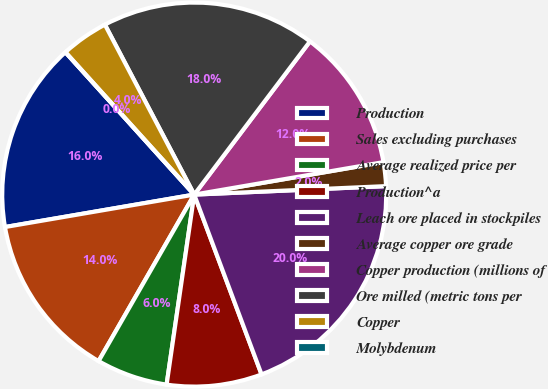<chart> <loc_0><loc_0><loc_500><loc_500><pie_chart><fcel>Production<fcel>Sales excluding purchases<fcel>Average realized price per<fcel>Production^a<fcel>Leach ore placed in stockpiles<fcel>Average copper ore grade<fcel>Copper production (millions of<fcel>Ore milled (metric tons per<fcel>Copper<fcel>Molybdenum<nl><fcel>16.0%<fcel>14.0%<fcel>6.0%<fcel>8.0%<fcel>20.0%<fcel>2.0%<fcel>12.0%<fcel>18.0%<fcel>4.0%<fcel>0.0%<nl></chart> 